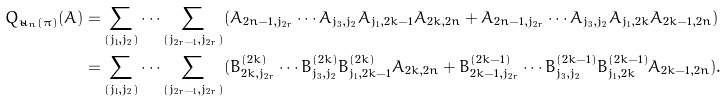Convert formula to latex. <formula><loc_0><loc_0><loc_500><loc_500>Q _ { \tilde { u } _ { n } ( \pi ) } ( A ) = & \sum _ { ( j _ { 1 } , j _ { 2 } ) } \cdots \sum _ { ( j _ { 2 r - 1 } , j _ { 2 r } ) } ( A _ { 2 n - 1 , j _ { 2 r } } \cdots A _ { j _ { 3 } , j _ { 2 } } A _ { j _ { 1 } , 2 k - 1 } A _ { 2 k , 2 n } + A _ { 2 n - 1 , j _ { 2 r } } \cdots A _ { j _ { 3 } , j _ { 2 } } A _ { j _ { 1 } , 2 k } A _ { 2 k - 1 , 2 n } ) \\ = & \sum _ { ( j _ { 1 } , j _ { 2 } ) } \cdots \sum _ { ( j _ { 2 r - 1 } , j _ { 2 r } ) } ( B _ { 2 k , j _ { 2 r } } ^ { ( 2 k ) } \cdots B ^ { ( 2 k ) } _ { j _ { 3 } , j _ { 2 } } B ^ { ( 2 k ) } _ { j _ { 1 } , 2 k - 1 } A _ { 2 k , 2 n } + B ^ { ( 2 k - 1 ) } _ { 2 k - 1 , j _ { 2 r } } \cdots B ^ { ( 2 k - 1 ) } _ { j _ { 3 } , j _ { 2 } } B ^ { ( 2 k - 1 ) } _ { j _ { 1 } , 2 k } A _ { 2 k - 1 , 2 n } ) .</formula> 